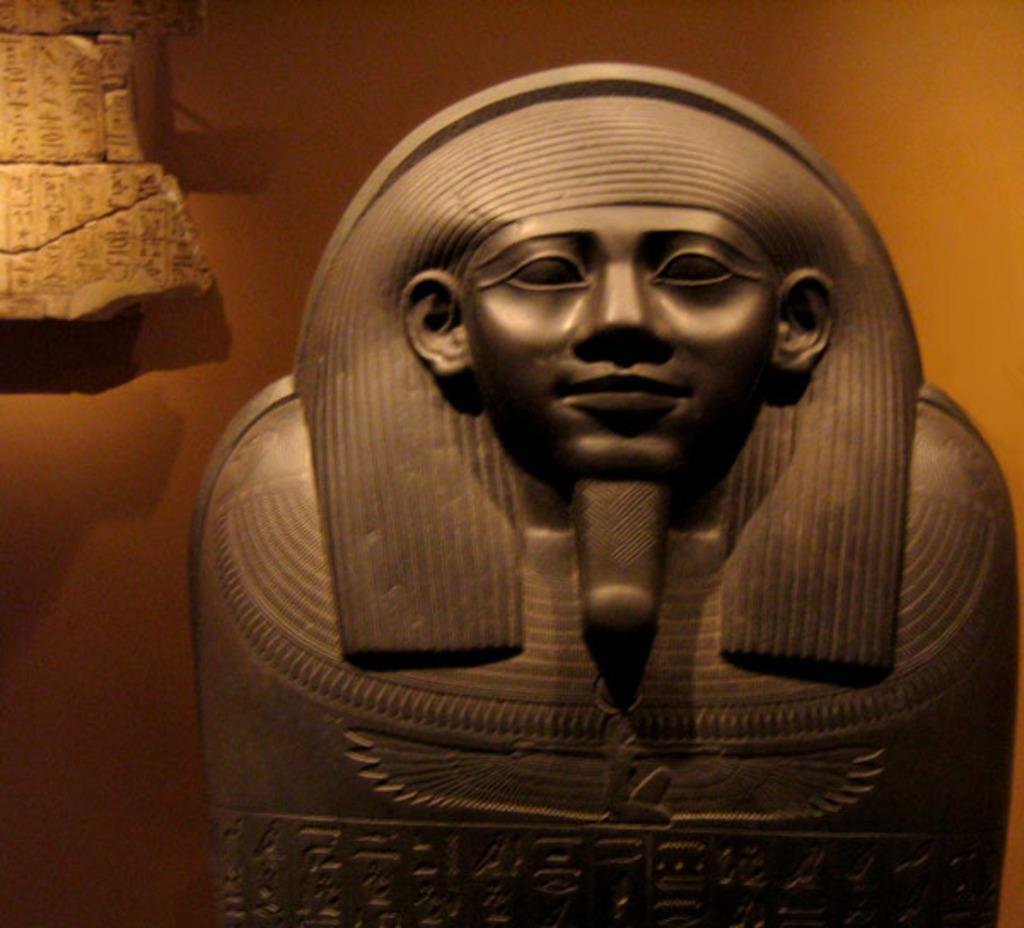What is the main subject in the center of the image? There is a sculpture in the center of the image. What can be seen in the background of the image? There is a wall in the background of the image. What type of bone can be seen in the image? There is no bone present in the image; it features a sculpture and a wall. What word is written on the wall in the image? There is no text visible on the wall in the image. 